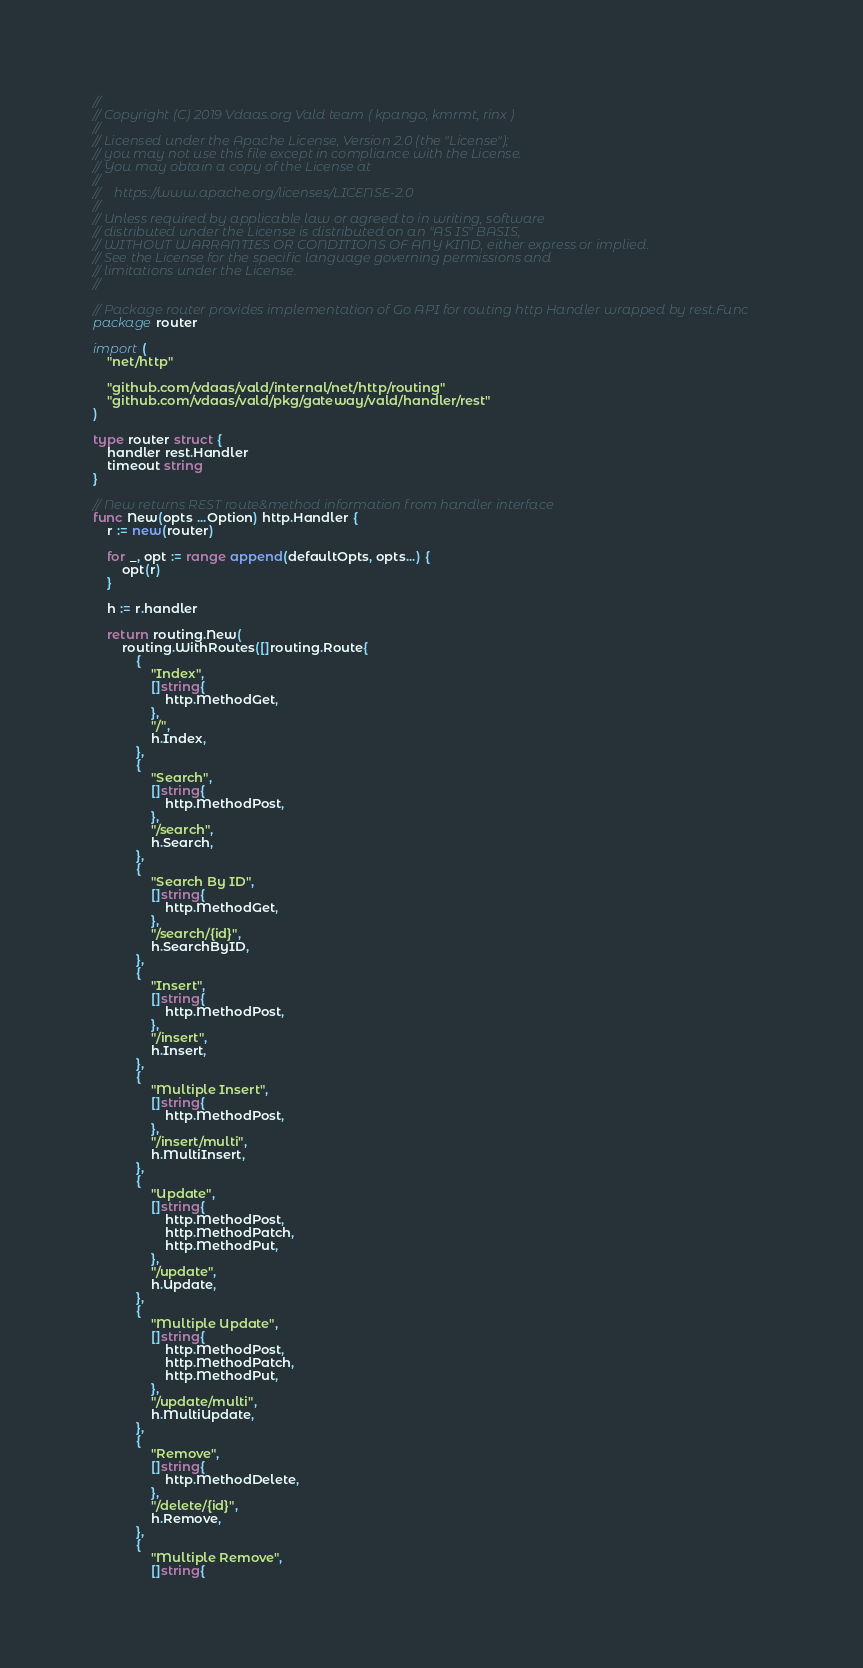<code> <loc_0><loc_0><loc_500><loc_500><_Go_>//
// Copyright (C) 2019 Vdaas.org Vald team ( kpango, kmrmt, rinx )
//
// Licensed under the Apache License, Version 2.0 (the "License");
// you may not use this file except in compliance with the License.
// You may obtain a copy of the License at
//
//    https://www.apache.org/licenses/LICENSE-2.0
//
// Unless required by applicable law or agreed to in writing, software
// distributed under the License is distributed on an "AS IS" BASIS,
// WITHOUT WARRANTIES OR CONDITIONS OF ANY KIND, either express or implied.
// See the License for the specific language governing permissions and
// limitations under the License.
//

// Package router provides implementation of Go API for routing http Handler wrapped by rest.Func
package router

import (
	"net/http"

	"github.com/vdaas/vald/internal/net/http/routing"
	"github.com/vdaas/vald/pkg/gateway/vald/handler/rest"
)

type router struct {
	handler rest.Handler
	timeout string
}

// New returns REST route&method information from handler interface
func New(opts ...Option) http.Handler {
	r := new(router)

	for _, opt := range append(defaultOpts, opts...) {
		opt(r)
	}

	h := r.handler

	return routing.New(
		routing.WithRoutes([]routing.Route{
			{
				"Index",
				[]string{
					http.MethodGet,
				},
				"/",
				h.Index,
			},
			{
				"Search",
				[]string{
					http.MethodPost,
				},
				"/search",
				h.Search,
			},
			{
				"Search By ID",
				[]string{
					http.MethodGet,
				},
				"/search/{id}",
				h.SearchByID,
			},
			{
				"Insert",
				[]string{
					http.MethodPost,
				},
				"/insert",
				h.Insert,
			},
			{
				"Multiple Insert",
				[]string{
					http.MethodPost,
				},
				"/insert/multi",
				h.MultiInsert,
			},
			{
				"Update",
				[]string{
					http.MethodPost,
					http.MethodPatch,
					http.MethodPut,
				},
				"/update",
				h.Update,
			},
			{
				"Multiple Update",
				[]string{
					http.MethodPost,
					http.MethodPatch,
					http.MethodPut,
				},
				"/update/multi",
				h.MultiUpdate,
			},
			{
				"Remove",
				[]string{
					http.MethodDelete,
				},
				"/delete/{id}",
				h.Remove,
			},
			{
				"Multiple Remove",
				[]string{</code> 